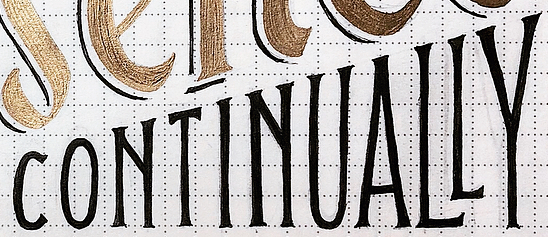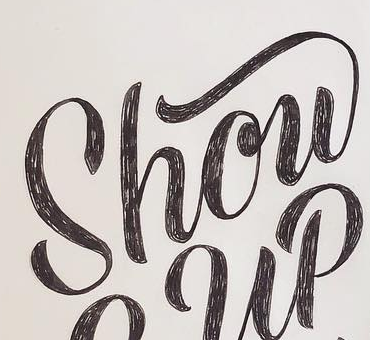Read the text content from these images in order, separated by a semicolon. CONTINUALLY; Show 